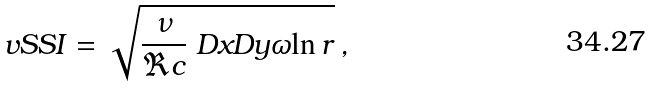<formula> <loc_0><loc_0><loc_500><loc_500>\ v S S I = \sqrt { \frac { \nu } { \Re c } \ D x D y { \omega } { \ln r } } \, ,</formula> 